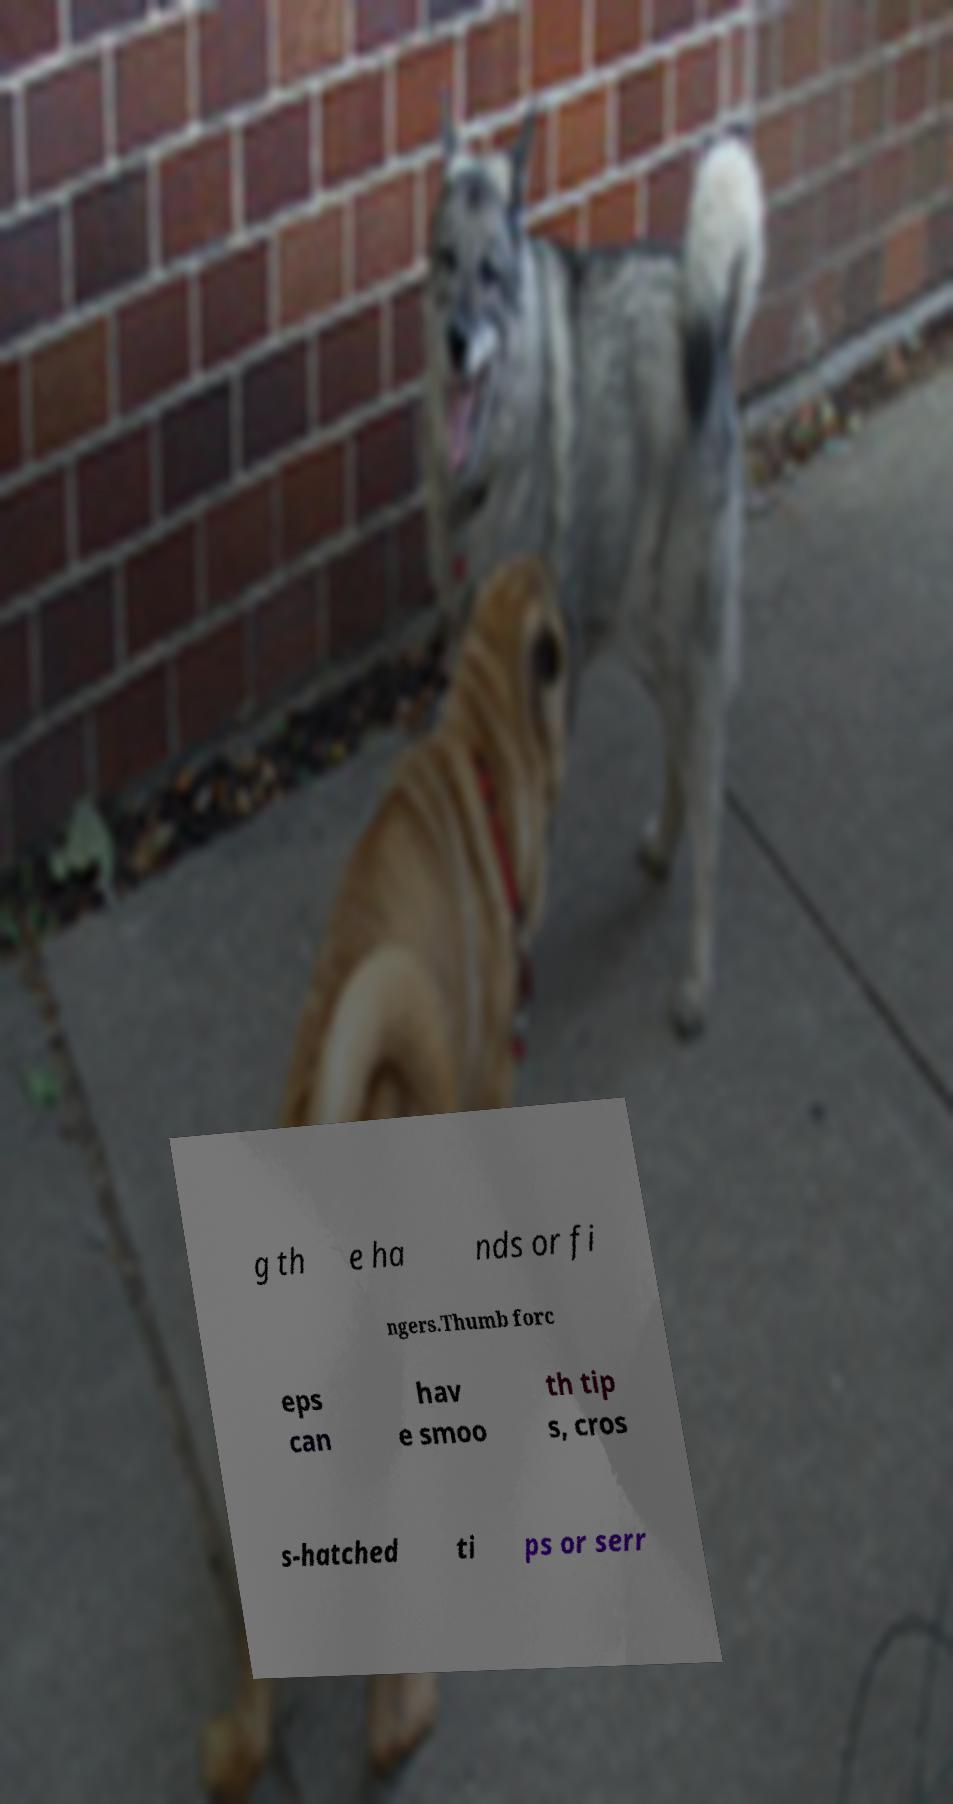Can you accurately transcribe the text from the provided image for me? g th e ha nds or fi ngers.Thumb forc eps can hav e smoo th tip s, cros s-hatched ti ps or serr 